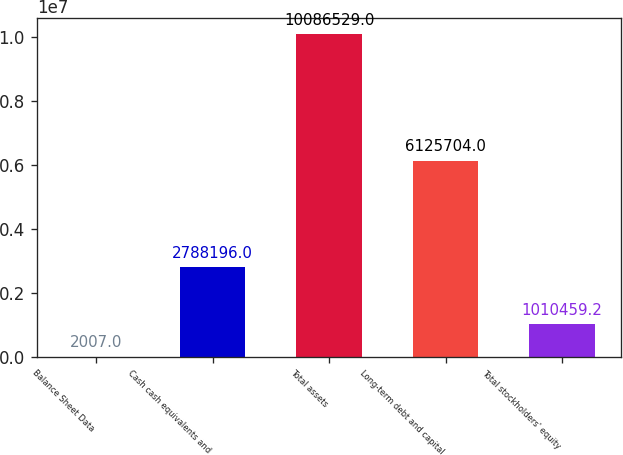Convert chart to OTSL. <chart><loc_0><loc_0><loc_500><loc_500><bar_chart><fcel>Balance Sheet Data<fcel>Cash cash equivalents and<fcel>Total assets<fcel>Long-term debt and capital<fcel>Total stockholders' equity<nl><fcel>2007<fcel>2.7882e+06<fcel>1.00865e+07<fcel>6.1257e+06<fcel>1.01046e+06<nl></chart> 